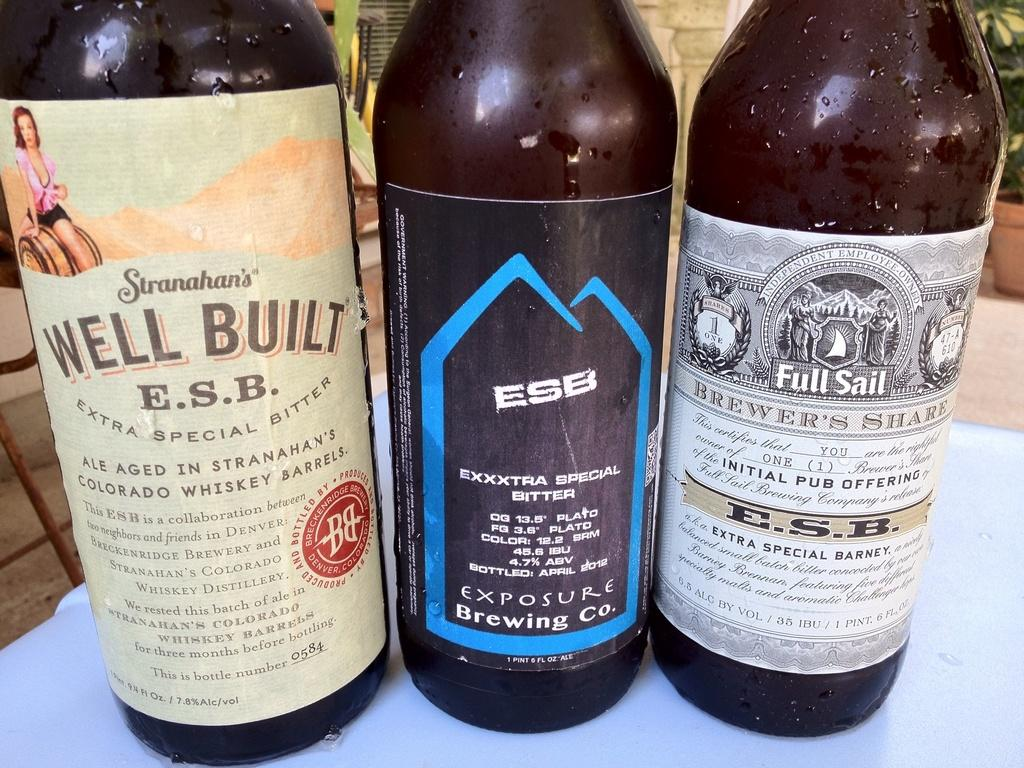<image>
Offer a succinct explanation of the picture presented. Three bottles of ESB branded alcohol are sitting next to each other. 